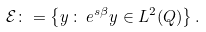<formula> <loc_0><loc_0><loc_500><loc_500>\mathcal { E } \colon = \left \{ y \, \colon \, e ^ { s \beta } y \in L ^ { 2 } ( Q ) \right \} .</formula> 